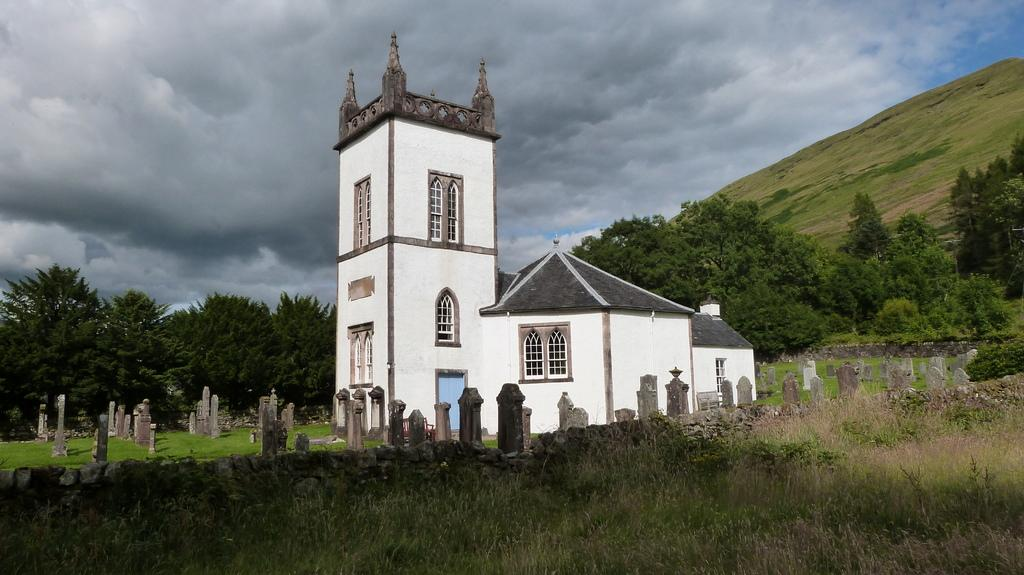What is the main subject in the center of the image? There is a graveyard and a building in the center of the image. What type of vegetation can be seen at the bottom of the image? Grass and plants are visible at the bottom of the image. What can be seen in the background of the image? There are trees, a hill, clouds, and the sky visible in the background of the image. What type of disease is affecting the trees in the image? There is no indication of any disease affecting the trees in the image; they appear to be healthy. Can you hear the bells ringing in the image? There are no bells present in the image, so it is not possible to hear them ringing. 